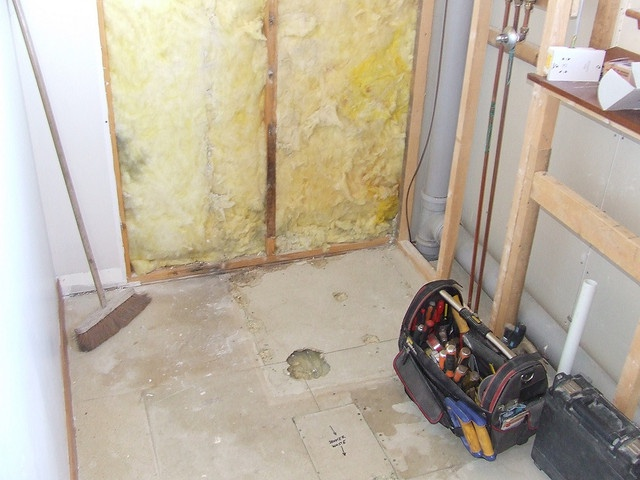Describe the objects in this image and their specific colors. I can see suitcase in white, black, gray, and maroon tones and suitcase in white, gray, and black tones in this image. 